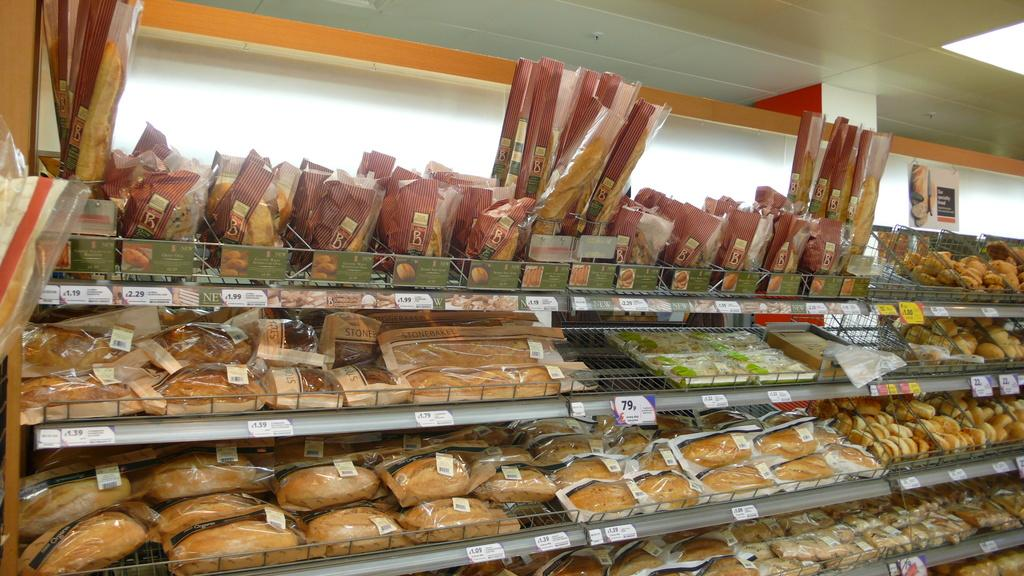What types of items can be seen in the image? There are food items in the image. Are there any indications of the cost of the items? Yes, price stickers are present in the image. What can be found in the racks in the image? There are objects in the racks. What is the background of the image? There is a wall behind the food items. What type of hospital can be seen in the image? There is no hospital present in the image; it features food items, price stickers, objects in racks, and a wall as the background. What kind of division is visible in the image? There is no division or separation mentioned in the image; it primarily focuses on food items, price stickers, objects in racks, and the wall. 